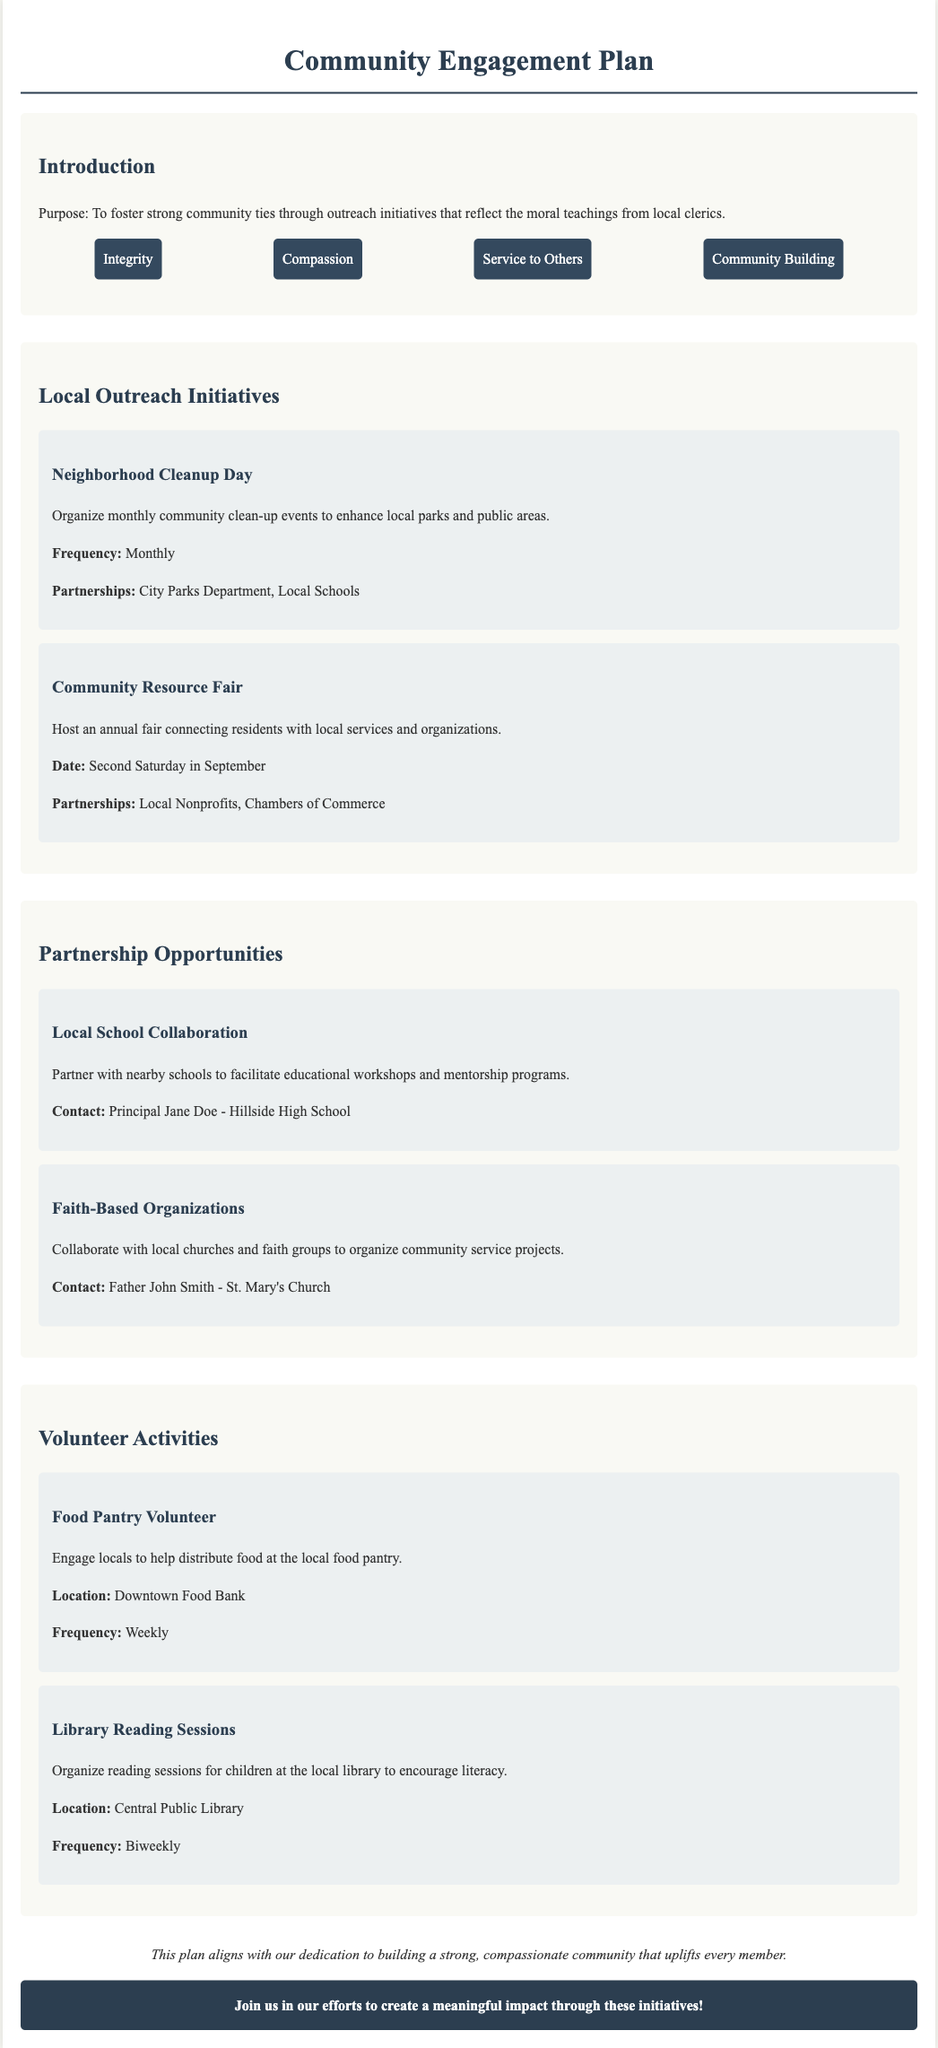What is the purpose of the Community Engagement Plan? The purpose is to foster strong community ties through outreach initiatives that reflect the moral teachings from local clerics.
Answer: Foster strong community ties How often is the Neighborhood Cleanup Day held? The document states that the Neighborhood Cleanup Day is organized monthly.
Answer: Monthly What date is the Community Resource Fair scheduled for? The Community Resource Fair is scheduled for the second Saturday in September.
Answer: Second Saturday in September Who can be contacted for the Local School Collaboration? The contact person for the Local School Collaboration is Principal Jane Doe.
Answer: Principal Jane Doe What is the frequency of the Food Pantry Volunteer activity? The frequency of the Food Pantry Volunteer activity is weekly.
Answer: Weekly Which location hosts the Library Reading Sessions? The Library Reading Sessions are held at the Central Public Library.
Answer: Central Public Library What values are emphasized in this community plan? The emphasized values in the community plan include Integrity, Compassion, Service to Others, and Community Building.
Answer: Integrity, Compassion, Service to Others, Community Building How does the plan describe the community it aims to build? The plan describes the community as strong and compassionate that uplifts every member.
Answer: Strong, compassionate community What type of organizations does the plan suggest partnering with for community service projects? The plan suggests collaborating with faith-based organizations for community service projects.
Answer: Faith-Based Organizations 